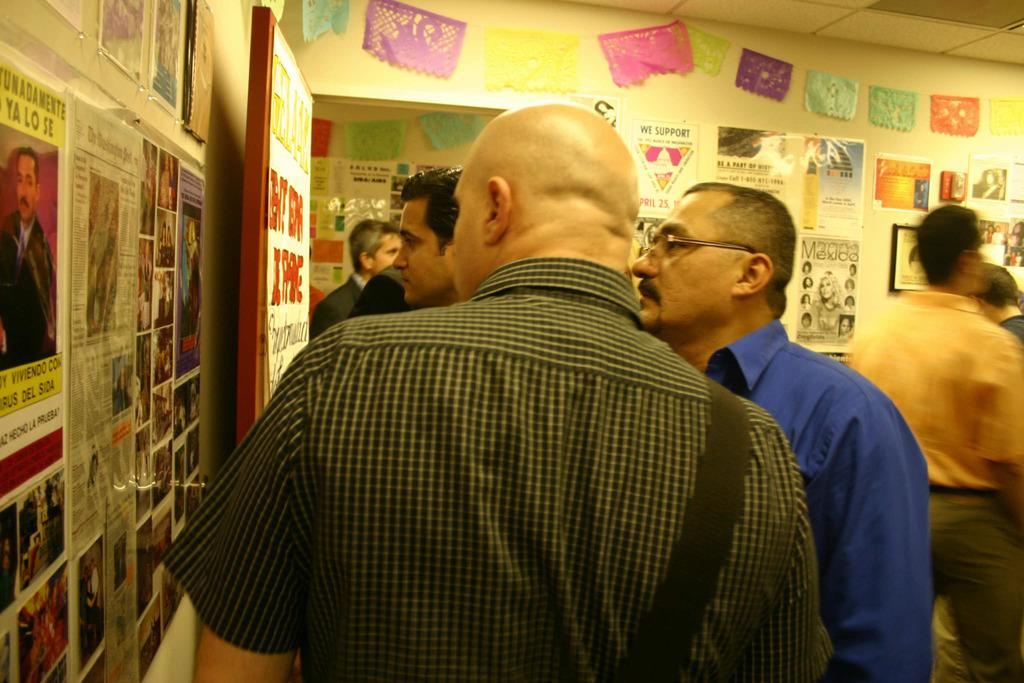Who or what is present in the image? There are people in the image. What architectural feature can be seen in the image? There is a door in the image. What surrounds the space in the image? There are walls in the image. What decorations are on the walls and door? There are posters on the walls and posters on the doors. What type of tax is being discussed on the posters in the image? There is no mention of tax on the posters in the image; they are not related to taxation. 